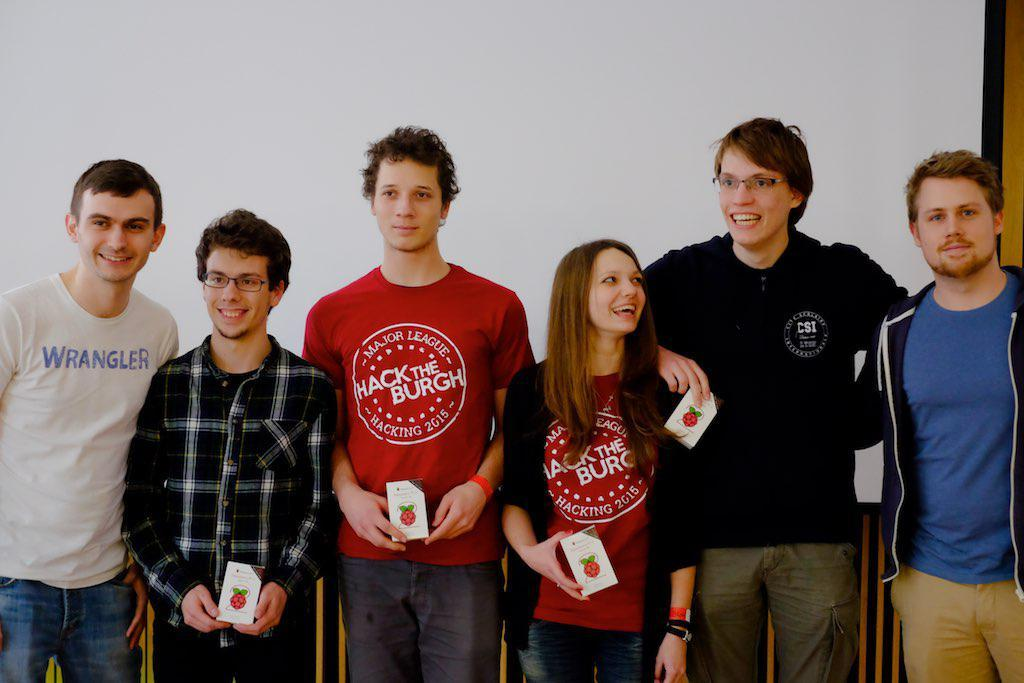<image>
Relay a brief, clear account of the picture shown. Individuals standing shoulder to shoulder with red shirts that say Mack the Burgh. 